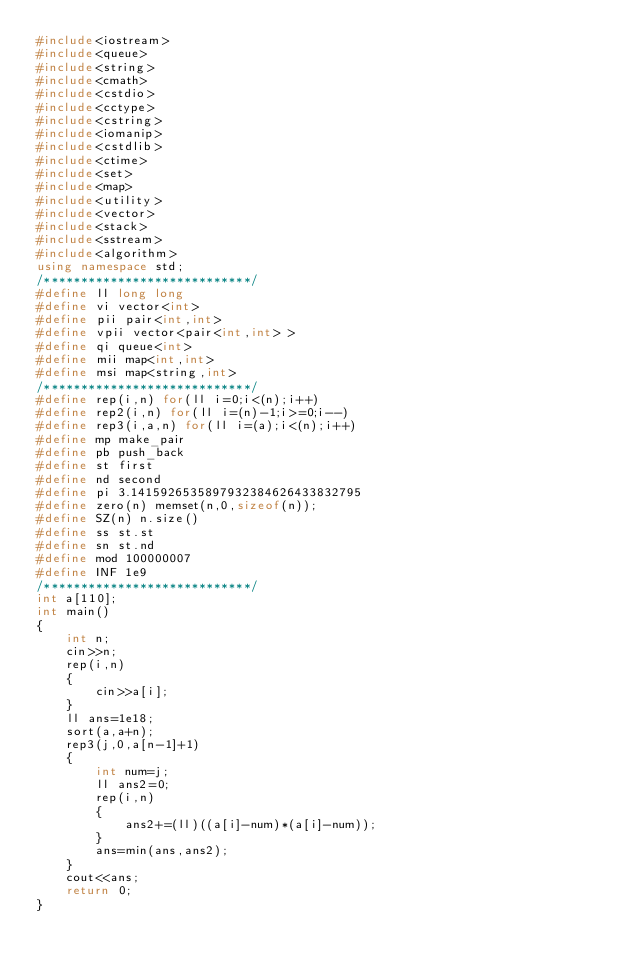Convert code to text. <code><loc_0><loc_0><loc_500><loc_500><_C++_>#include<iostream>
#include<queue>
#include<string>
#include<cmath>
#include<cstdio>
#include<cctype>
#include<cstring>
#include<iomanip>
#include<cstdlib>
#include<ctime>
#include<set>
#include<map>
#include<utility>
#include<vector>
#include<stack>
#include<sstream>
#include<algorithm>
using namespace std;
/****************************/
#define ll long long
#define vi vector<int>
#define pii pair<int,int>
#define vpii vector<pair<int,int> >
#define qi queue<int>
#define mii map<int,int>
#define msi map<string,int>
/****************************/
#define rep(i,n) for(ll i=0;i<(n);i++)
#define rep2(i,n) for(ll i=(n)-1;i>=0;i--)
#define rep3(i,a,n) for(ll i=(a);i<(n);i++)
#define mp make_pair
#define pb push_back
#define st first
#define nd second
#define pi 3.1415926535897932384626433832795
#define zero(n) memset(n,0,sizeof(n));
#define SZ(n) n.size()
#define ss st.st
#define sn st.nd
#define mod 100000007
#define INF 1e9
/****************************/
int a[110];
int main()
{
	int n;
	cin>>n;
	rep(i,n)
	{
		cin>>a[i];
	}
	ll ans=1e18;
	sort(a,a+n);
	rep3(j,0,a[n-1]+1)
	{
		int num=j;
		ll ans2=0;
		rep(i,n)
		{
			ans2+=(ll)((a[i]-num)*(a[i]-num));
		}
		ans=min(ans,ans2);
	}
	cout<<ans;
	return 0;
}</code> 